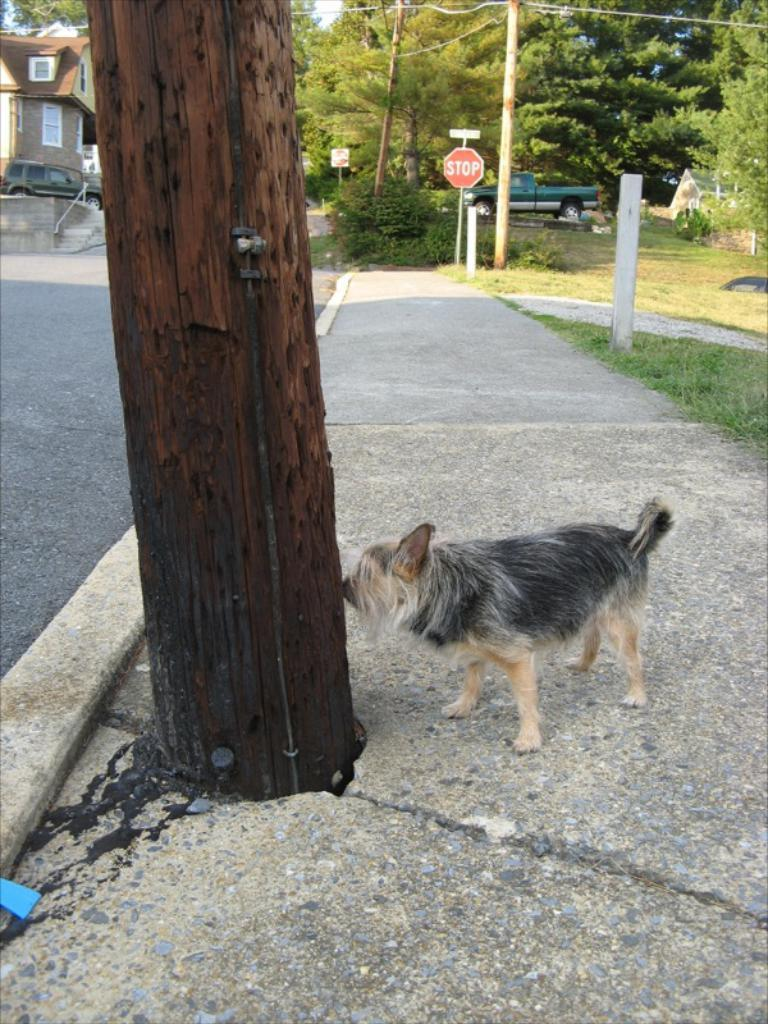What type of animal can be seen in the image? There is a dog in the image. Where is the dog positioned in relation to the tree trunk? The dog is standing in front of a tree trunk. What can be seen in the background of the image? There are vehicles, trees, and a building in the background of the image. What answer does the stranger provide to the dog's question in the image? There is no stranger or question from the dog present in the image. What unit of measurement is used to determine the dog's height in the image? There is no need to determine the dog's height in the image, and no unit of measurement is mentioned or implied. 